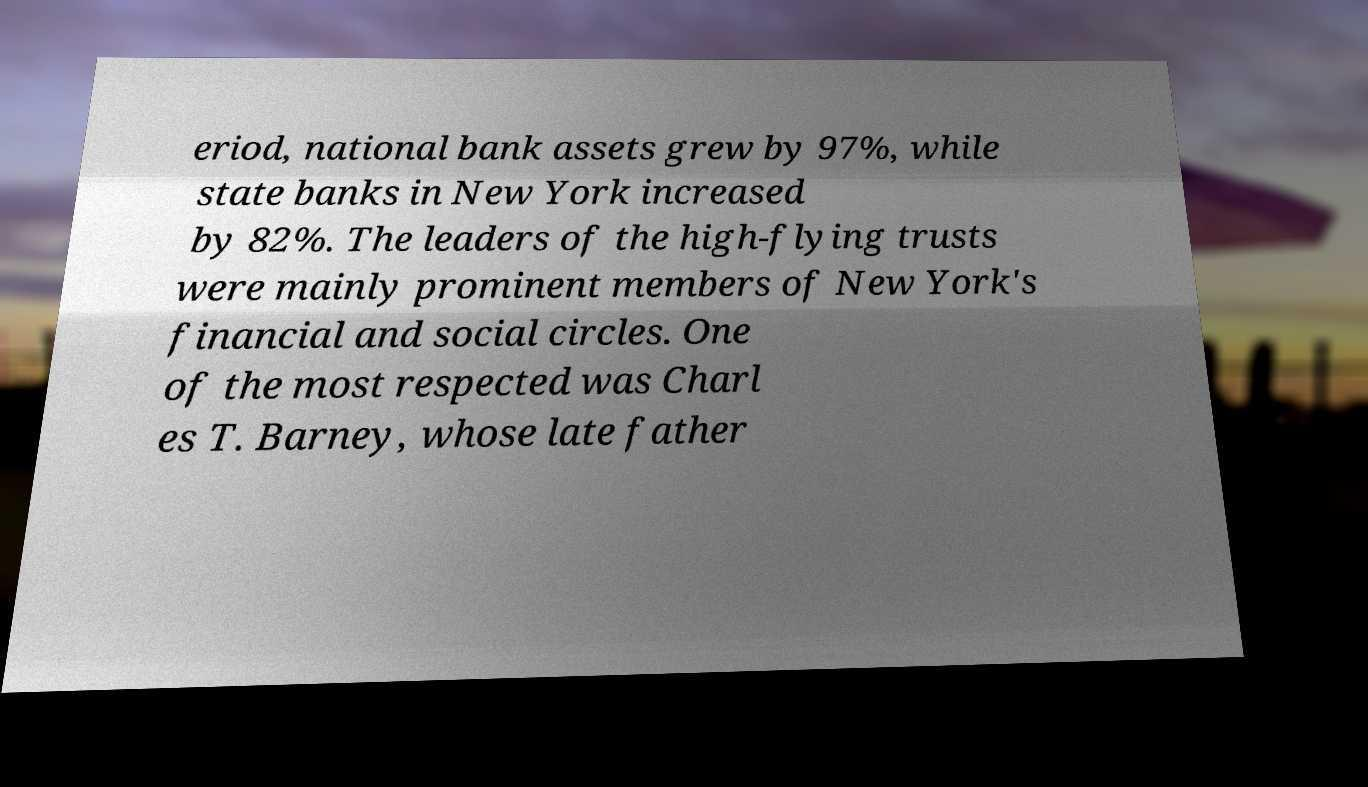Please identify and transcribe the text found in this image. eriod, national bank assets grew by 97%, while state banks in New York increased by 82%. The leaders of the high-flying trusts were mainly prominent members of New York's financial and social circles. One of the most respected was Charl es T. Barney, whose late father 